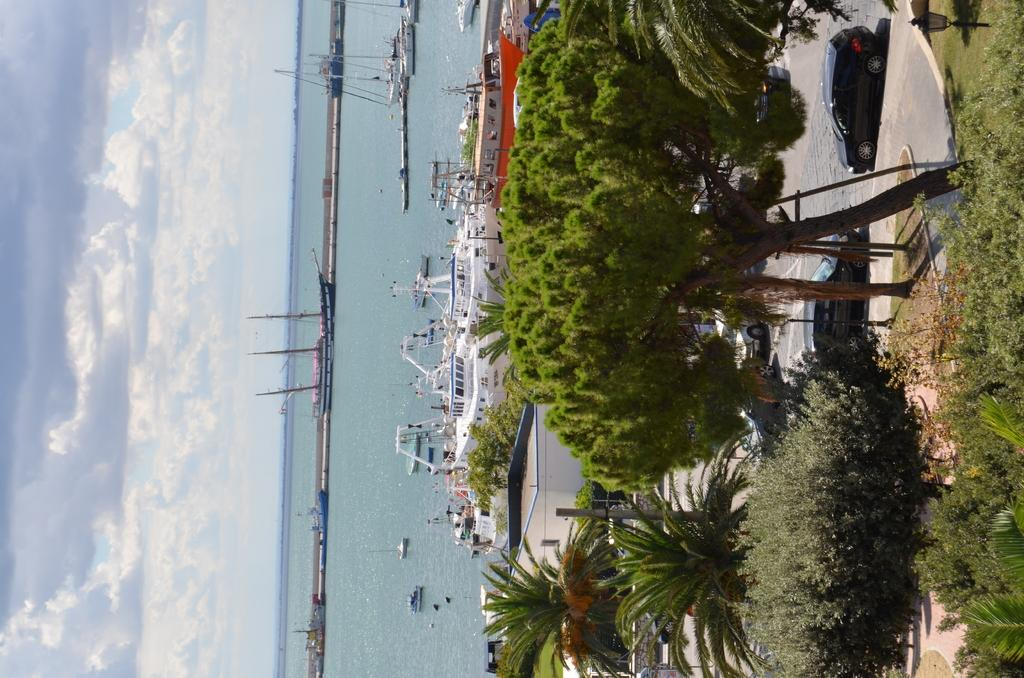What can be seen on the water in the image? There are ships on the water in the image. What type of vegetation is visible in the image? There are trees and bushes visible in the image. What type of transportation is present on the road in the image? Motor vehicles are present on the road in the image. What type of structures can be seen in the image? There are buildings in the image. What type of lighting is present in the image? There is a street light in the image. What type of pole is present in the image? There is a street pole in the image. What is visible in the sky in the image? The sky is visible in the image with clouds. What type of learning tool is being used by the wrench in the image? There is no wrench present in the image, so it cannot be used as a learning tool. How does the grip of the person holding the street pole affect the image? There is no person holding the street pole in the image, so their grip cannot affect the image. 